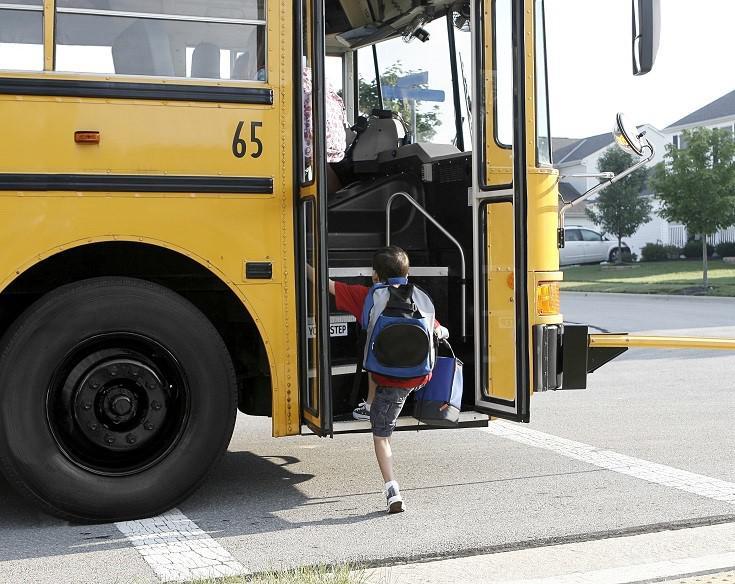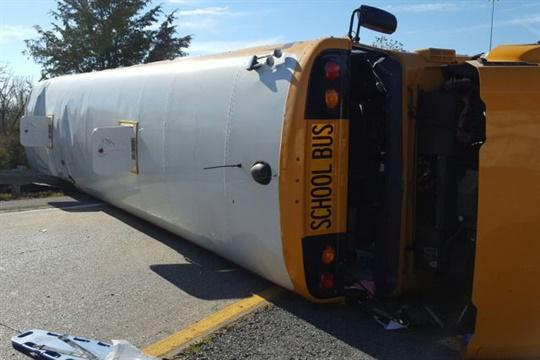The first image is the image on the left, the second image is the image on the right. For the images shown, is this caption "In three of the images, the school bus is laying on it's side." true? Answer yes or no. Yes. The first image is the image on the left, the second image is the image on the right. For the images displayed, is the sentence "The right image contains a school bus that is flipped onto its side." factually correct? Answer yes or no. Yes. 